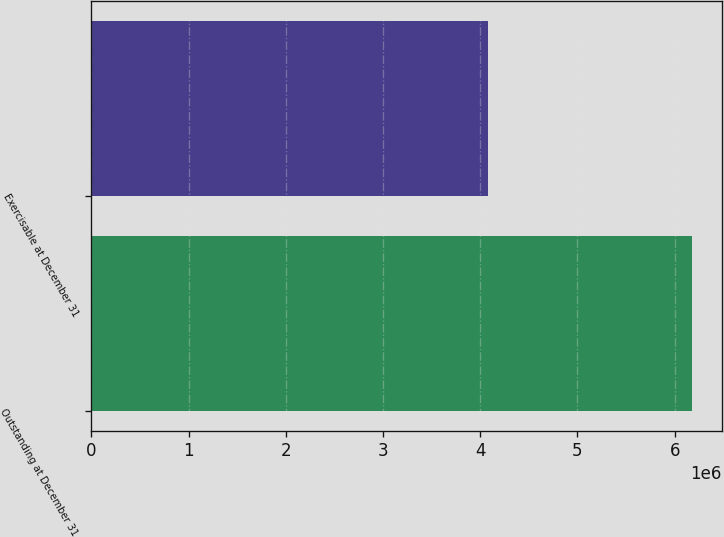Convert chart. <chart><loc_0><loc_0><loc_500><loc_500><bar_chart><fcel>Outstanding at December 31<fcel>Exercisable at December 31<nl><fcel>6.17506e+06<fcel>4.0831e+06<nl></chart> 